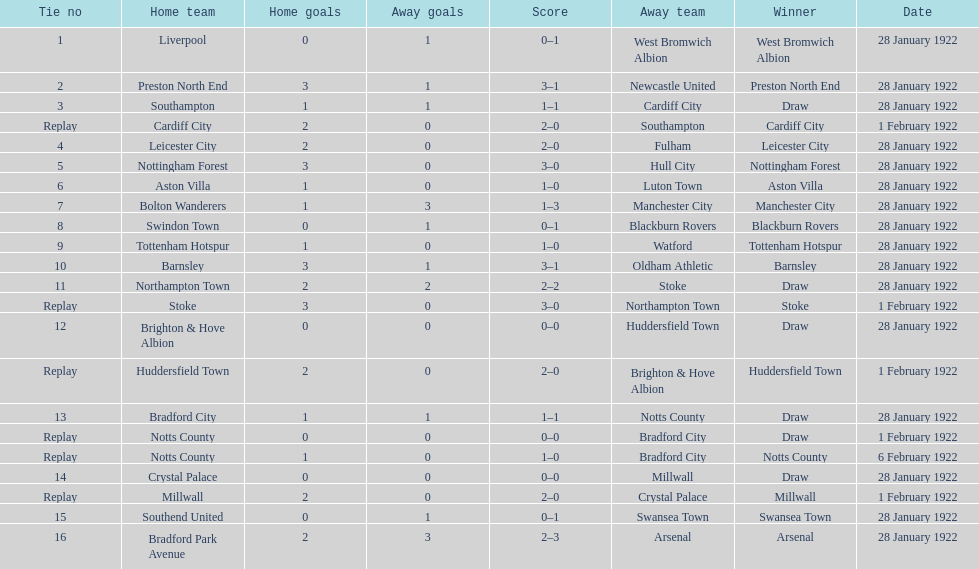Who is the first home team listed as having a score of 3-1? Preston North End. 